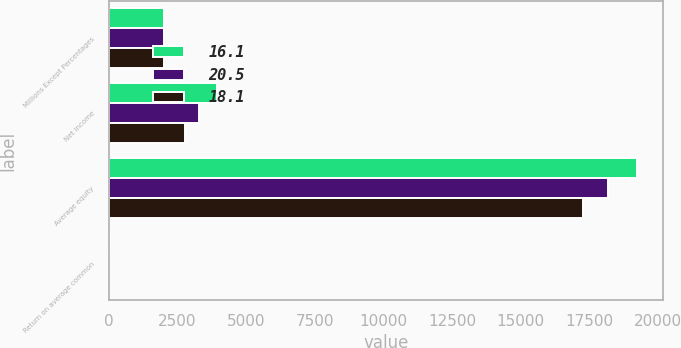<chart> <loc_0><loc_0><loc_500><loc_500><stacked_bar_chart><ecel><fcel>Millions Except Percentages<fcel>Net income<fcel>Average equity<fcel>Return on average common<nl><fcel>16.1<fcel>2012<fcel>3943<fcel>19228<fcel>20.5<nl><fcel>20.5<fcel>2011<fcel>3292<fcel>18171<fcel>18.1<nl><fcel>18.1<fcel>2010<fcel>2780<fcel>17282<fcel>16.1<nl></chart> 